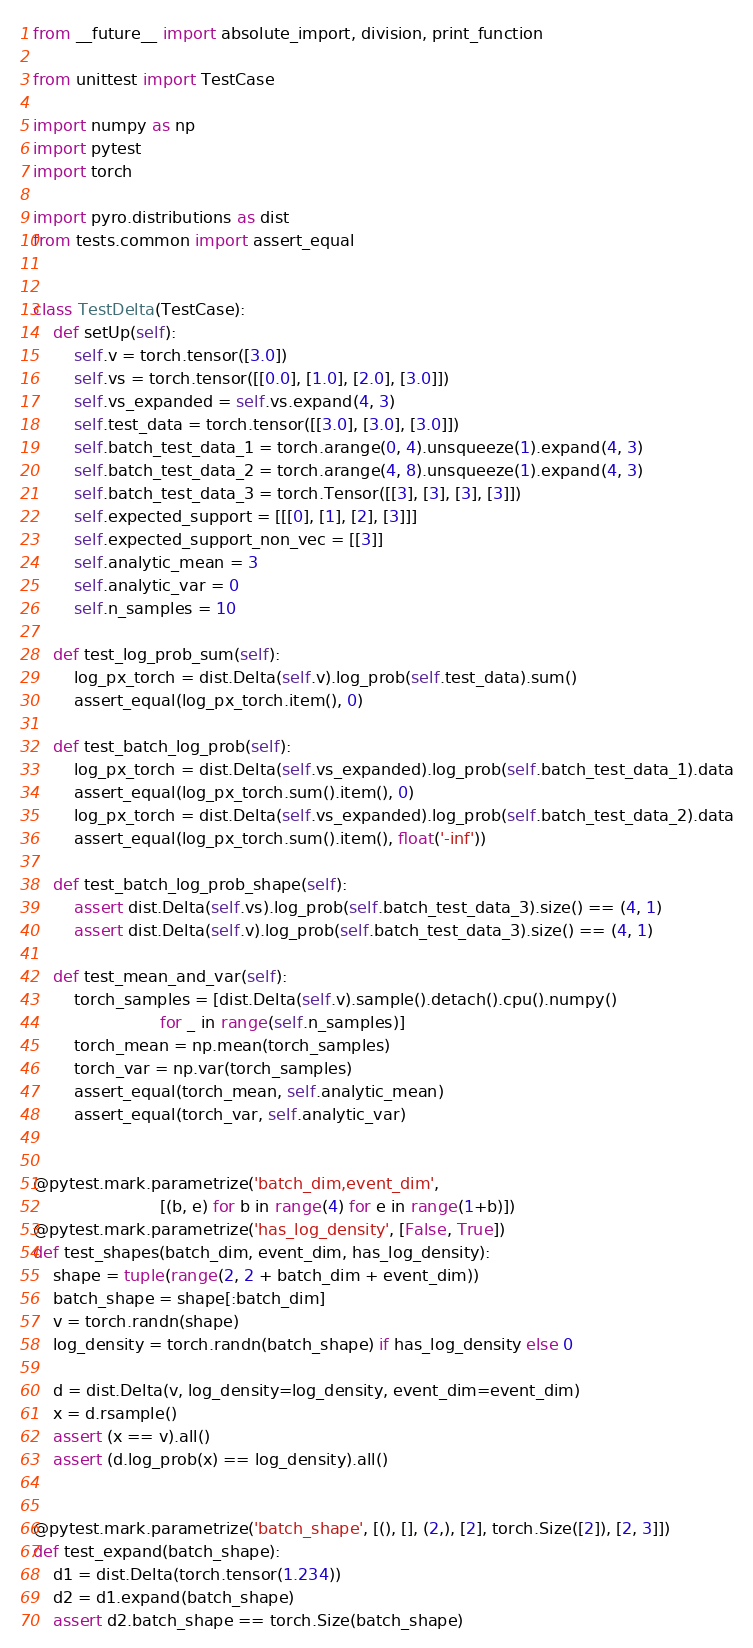Convert code to text. <code><loc_0><loc_0><loc_500><loc_500><_Python_>from __future__ import absolute_import, division, print_function

from unittest import TestCase

import numpy as np
import pytest
import torch

import pyro.distributions as dist
from tests.common import assert_equal


class TestDelta(TestCase):
    def setUp(self):
        self.v = torch.tensor([3.0])
        self.vs = torch.tensor([[0.0], [1.0], [2.0], [3.0]])
        self.vs_expanded = self.vs.expand(4, 3)
        self.test_data = torch.tensor([[3.0], [3.0], [3.0]])
        self.batch_test_data_1 = torch.arange(0, 4).unsqueeze(1).expand(4, 3)
        self.batch_test_data_2 = torch.arange(4, 8).unsqueeze(1).expand(4, 3)
        self.batch_test_data_3 = torch.Tensor([[3], [3], [3], [3]])
        self.expected_support = [[[0], [1], [2], [3]]]
        self.expected_support_non_vec = [[3]]
        self.analytic_mean = 3
        self.analytic_var = 0
        self.n_samples = 10

    def test_log_prob_sum(self):
        log_px_torch = dist.Delta(self.v).log_prob(self.test_data).sum()
        assert_equal(log_px_torch.item(), 0)

    def test_batch_log_prob(self):
        log_px_torch = dist.Delta(self.vs_expanded).log_prob(self.batch_test_data_1).data
        assert_equal(log_px_torch.sum().item(), 0)
        log_px_torch = dist.Delta(self.vs_expanded).log_prob(self.batch_test_data_2).data
        assert_equal(log_px_torch.sum().item(), float('-inf'))

    def test_batch_log_prob_shape(self):
        assert dist.Delta(self.vs).log_prob(self.batch_test_data_3).size() == (4, 1)
        assert dist.Delta(self.v).log_prob(self.batch_test_data_3).size() == (4, 1)

    def test_mean_and_var(self):
        torch_samples = [dist.Delta(self.v).sample().detach().cpu().numpy()
                         for _ in range(self.n_samples)]
        torch_mean = np.mean(torch_samples)
        torch_var = np.var(torch_samples)
        assert_equal(torch_mean, self.analytic_mean)
        assert_equal(torch_var, self.analytic_var)


@pytest.mark.parametrize('batch_dim,event_dim',
                         [(b, e) for b in range(4) for e in range(1+b)])
@pytest.mark.parametrize('has_log_density', [False, True])
def test_shapes(batch_dim, event_dim, has_log_density):
    shape = tuple(range(2, 2 + batch_dim + event_dim))
    batch_shape = shape[:batch_dim]
    v = torch.randn(shape)
    log_density = torch.randn(batch_shape) if has_log_density else 0

    d = dist.Delta(v, log_density=log_density, event_dim=event_dim)
    x = d.rsample()
    assert (x == v).all()
    assert (d.log_prob(x) == log_density).all()


@pytest.mark.parametrize('batch_shape', [(), [], (2,), [2], torch.Size([2]), [2, 3]])
def test_expand(batch_shape):
    d1 = dist.Delta(torch.tensor(1.234))
    d2 = d1.expand(batch_shape)
    assert d2.batch_shape == torch.Size(batch_shape)
</code> 